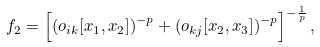Convert formula to latex. <formula><loc_0><loc_0><loc_500><loc_500>f _ { 2 } = \left [ { \left ( { o _ { i k } [ x _ { 1 } , x _ { 2 } ] } \right ) } ^ { - p } + { \left ( o _ { k j } [ x _ { 2 } , x _ { 3 } ] \right ) } ^ { - p } \right ] ^ { - \frac { 1 } { p } } ,</formula> 